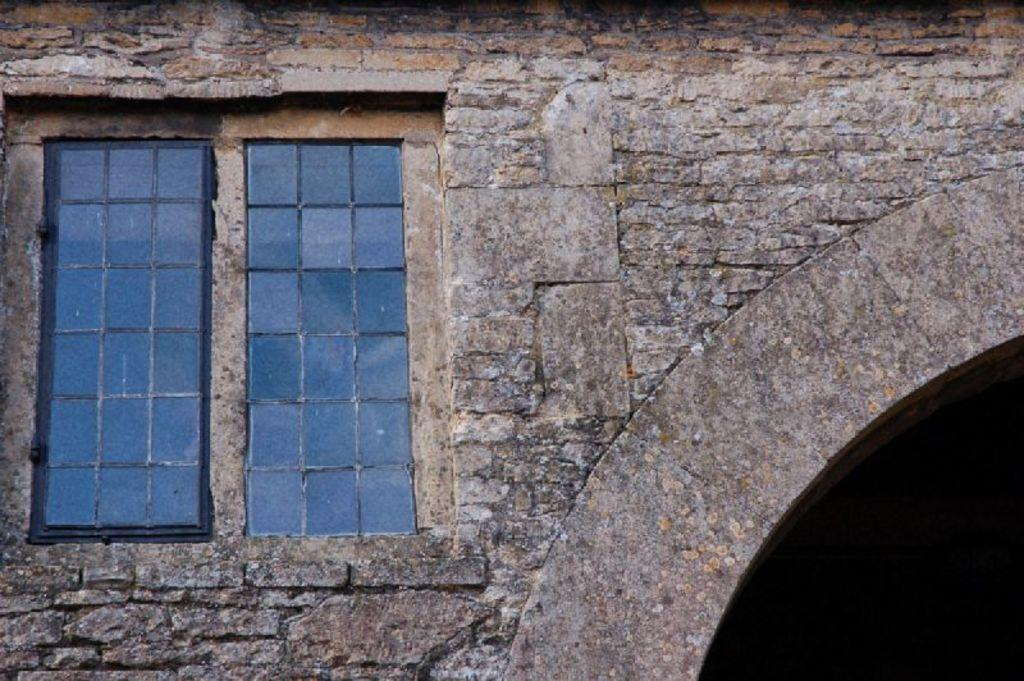What type of building is in the image? There is a stone constructed building in the building in the image. Can you describe any specific features of the building? There is a window in the building. How many children are playing near the beetle on the rail in the image? There are no children, beetles, or rails present in the image. 